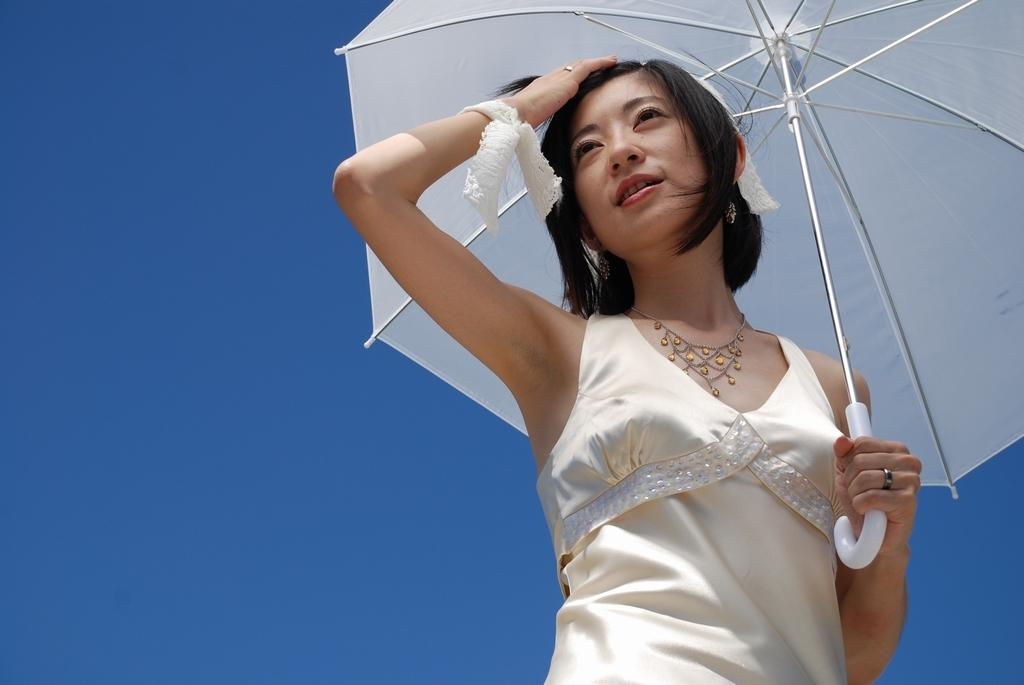Who is the main subject in the image? There is a woman in the image. What is the woman wearing? The woman is wearing a dress. What object is the woman holding in the image? The woman is holding an umbrella. What can be seen in the background of the image? There is sky visible in the background of the image. How much salt is on the woman's dress in the image? There is no salt visible on the woman's dress in the image. Is there a basket present in the image? No, there is no basket present in the image. 